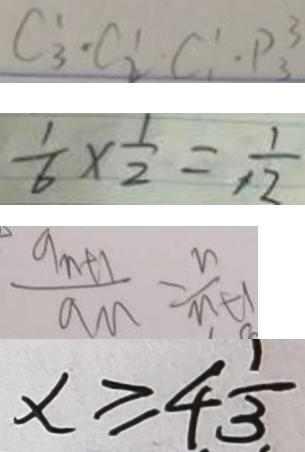<formula> <loc_0><loc_0><loc_500><loc_500>C ^ { 1 } _ { 3 } \cdot C _ { 2 } ^ { 1 } \cdot C ^ { 1 } _ { 1 } \cdot P _ { 3 } ^ { 3 } 
 \frac { 1 } { 6 } \times \frac { 1 } { 2 } = \frac { 1 } { 1 2 } 
 \frac { a _ { n + 1 } } { a _ { n } } = \frac { n } { n + 1 } 
 x \geq 4 \frac { 1 } { 3 }</formula> 